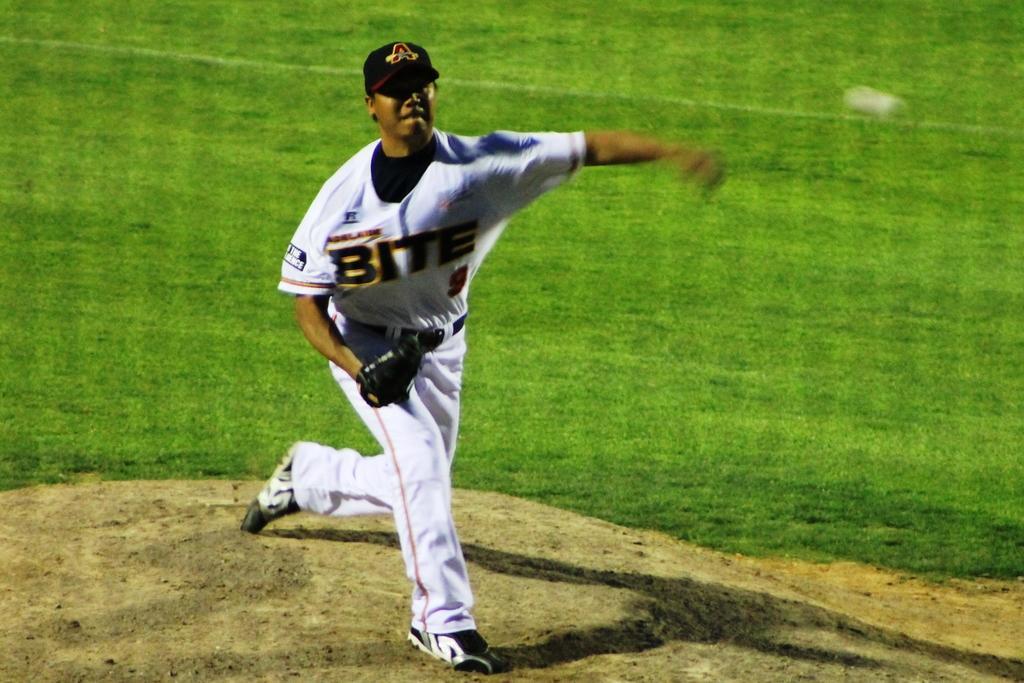In one or two sentences, can you explain what this image depicts? In this image in the center there is one person who is throwing a ball, at the bottom there is grass and sand. 